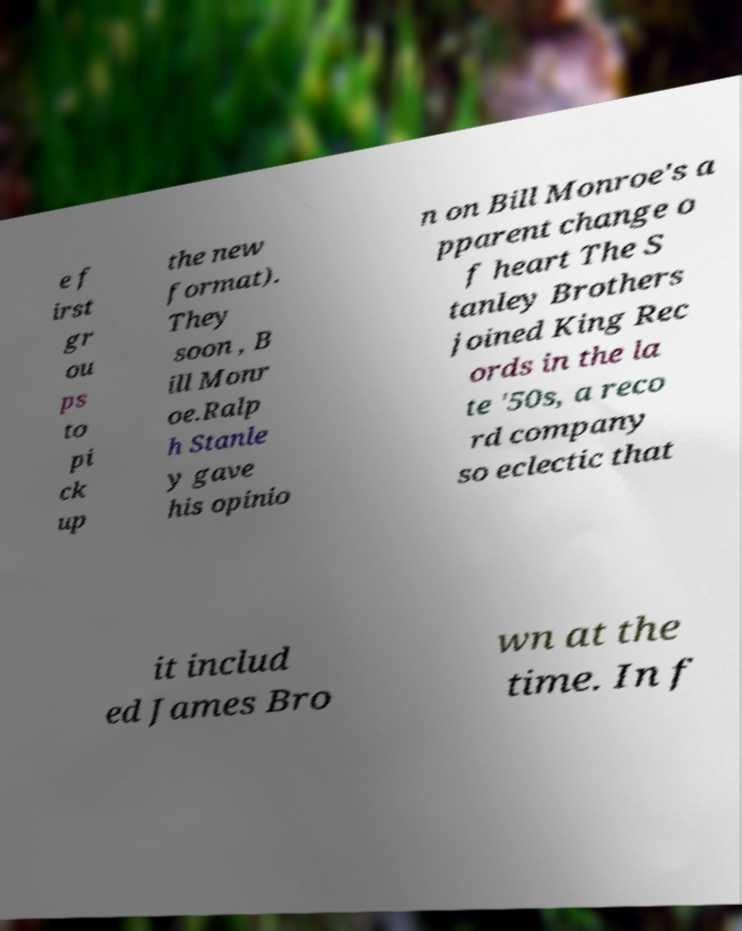Please read and relay the text visible in this image. What does it say? e f irst gr ou ps to pi ck up the new format). They soon , B ill Monr oe.Ralp h Stanle y gave his opinio n on Bill Monroe's a pparent change o f heart The S tanley Brothers joined King Rec ords in the la te '50s, a reco rd company so eclectic that it includ ed James Bro wn at the time. In f 